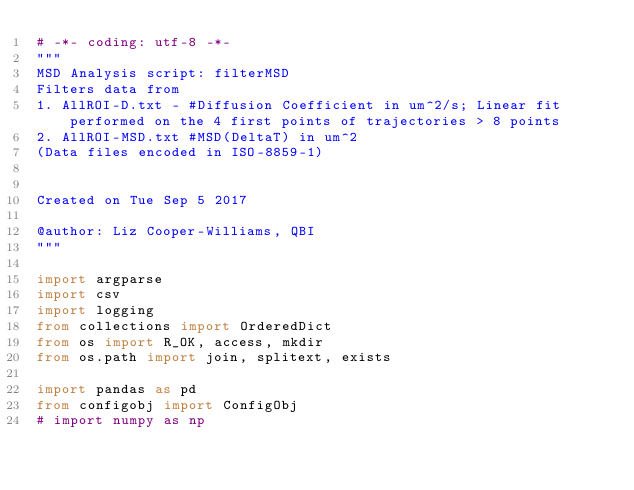Convert code to text. <code><loc_0><loc_0><loc_500><loc_500><_Python_># -*- coding: utf-8 -*-
"""
MSD Analysis script: filterMSD
Filters data from
1. AllROI-D.txt - #Diffusion Coefficient in um^2/s; Linear fit performed on the 4 first points of trajectories > 8 points
2. AllROI-MSD.txt #MSD(DeltaT) in um^2
(Data files encoded in ISO-8859-1)


Created on Tue Sep 5 2017

@author: Liz Cooper-Williams, QBI
"""

import argparse
import csv
import logging
from collections import OrderedDict
from os import R_OK, access, mkdir
from os.path import join, splitext, exists

import pandas as pd
from configobj import ConfigObj
# import numpy as np</code> 